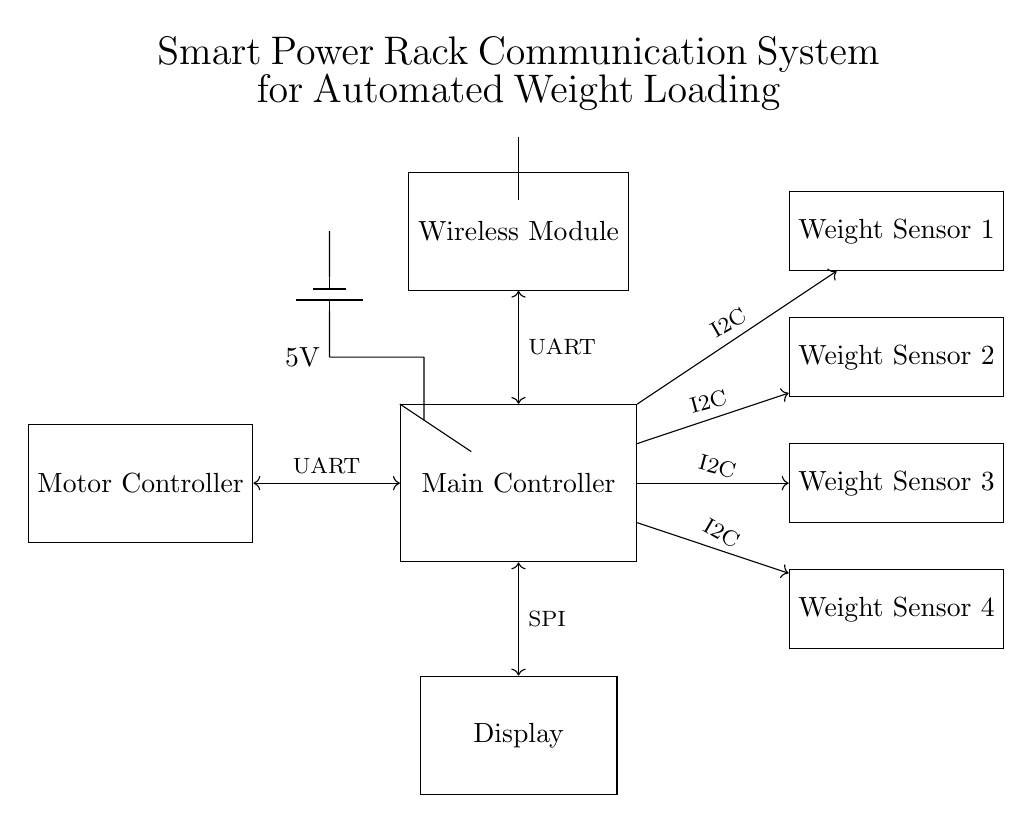What is the main function of the Main Controller? The Main Controller acts as the central processing unit that manages communication with all connected components, including weight sensors, motor controller, display, and wireless module.
Answer: central processing unit How many weight sensors are there in the circuit? The circuit diagram shows four weight sensors labeled Weight Sensor 1 to Weight Sensor 4.
Answer: four What type of connection is used between the Main Controller and the Motor Controller? The diagram indicates a bidirectional connection labeled UART (Universal Asynchronous Receiver-Transmitter) between the Main Controller and the Motor Controller.
Answer: UART What voltage supply is used for the circuit? The circuit specifies a battery supplying a voltage of 5V to the Main Controller, indicating the operational voltage for the system.
Answer: 5V Which communication protocol is used for the connection to the Display? The diagram shows the connection to the Display using the SPI (Serial Peripheral Interface) protocol, which is a type of synchronous serial communication.
Answer: SPI Why is a wireless module included in the system? The Wireless Module allows for wireless communication with external devices, facilitating remote control and data transmission for the Smart Power Rack.
Answer: wireless communication What is the purpose of the weight sensors in this circuit? The weight sensors measure the weight of the loaded barbell, allowing the Main Controller to automatically adjust the weights based on user input and exercise requirements.
Answer: measure weight 